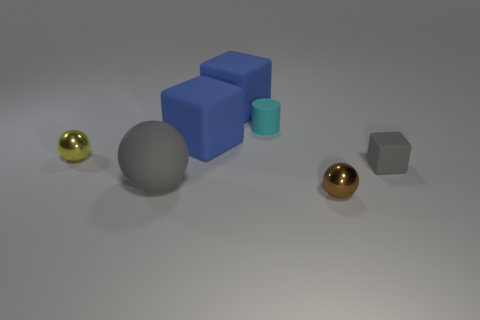Is the number of tiny matte blocks that are to the right of the yellow metallic object the same as the number of brown shiny objects?
Keep it short and to the point. Yes. What number of things are brown shiny objects or tiny blue metal cylinders?
Ensure brevity in your answer.  1. Are there any other things that have the same shape as the cyan rubber thing?
Ensure brevity in your answer.  No. The small rubber object that is to the left of the shiny thing in front of the large gray matte sphere is what shape?
Offer a very short reply. Cylinder. What is the shape of the tiny cyan object that is the same material as the big ball?
Keep it short and to the point. Cylinder. What size is the shiny sphere on the right side of the tiny rubber thing that is behind the tiny gray thing?
Give a very brief answer. Small. What is the shape of the tiny yellow object?
Offer a terse response. Sphere. What number of big objects are either rubber things or brown metal things?
Provide a succinct answer. 3. What size is the yellow object that is the same shape as the large gray thing?
Give a very brief answer. Small. How many rubber cubes are both in front of the rubber cylinder and behind the cylinder?
Offer a very short reply. 0. 